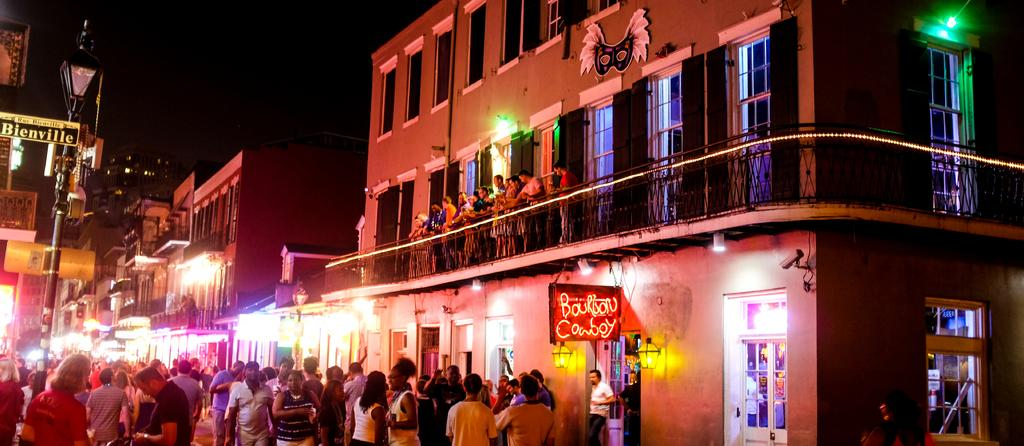How many people are in the image? There is a group of people in the image, but the exact number cannot be determined from the provided facts. What is visible in the background of the image? There is a building in the background of the image. What type of structures can be seen in the image? There are light poles in the image. What type of pear is being used as an example in the image? There is no pear present in the image. 